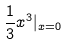<formula> <loc_0><loc_0><loc_500><loc_500>\frac { 1 } { 3 } x ^ { 3 } | _ { x = 0 }</formula> 